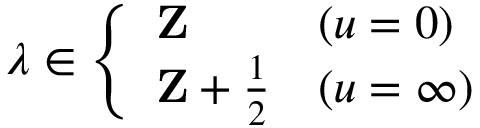<formula> <loc_0><loc_0><loc_500><loc_500>\lambda \in \left \{ \begin{array} { l l } { Z } & { ( u = 0 ) } \\ { { { Z } + \frac { 1 } { 2 } } } & { ( u = \infty ) } \end{array}</formula> 